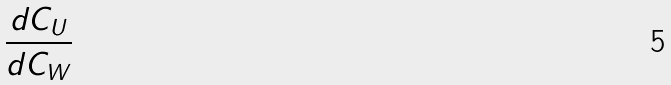<formula> <loc_0><loc_0><loc_500><loc_500>\frac { d C _ { U } } { d C _ { W } }</formula> 